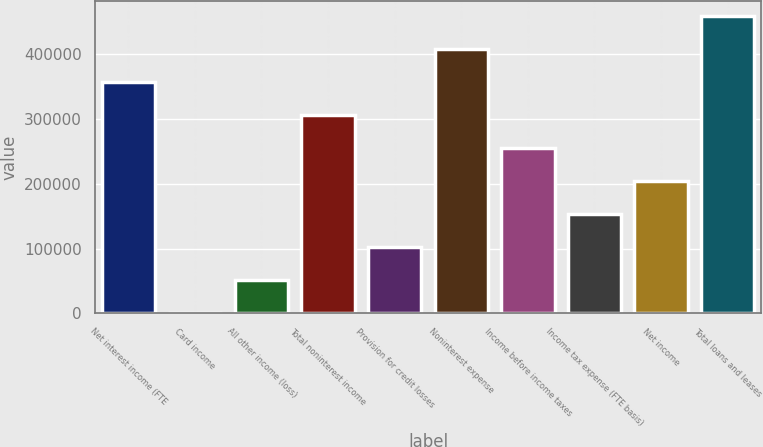Convert chart. <chart><loc_0><loc_0><loc_500><loc_500><bar_chart><fcel>Net interest income (FTE<fcel>Card income<fcel>All other income (loss)<fcel>Total noninterest income<fcel>Provision for credit losses<fcel>Noninterest expense<fcel>Income before income taxes<fcel>Income tax expense (FTE basis)<fcel>Net income<fcel>Total loans and leases<nl><fcel>357287<fcel>62<fcel>51094.2<fcel>306255<fcel>102126<fcel>408320<fcel>255223<fcel>153159<fcel>204191<fcel>459352<nl></chart> 